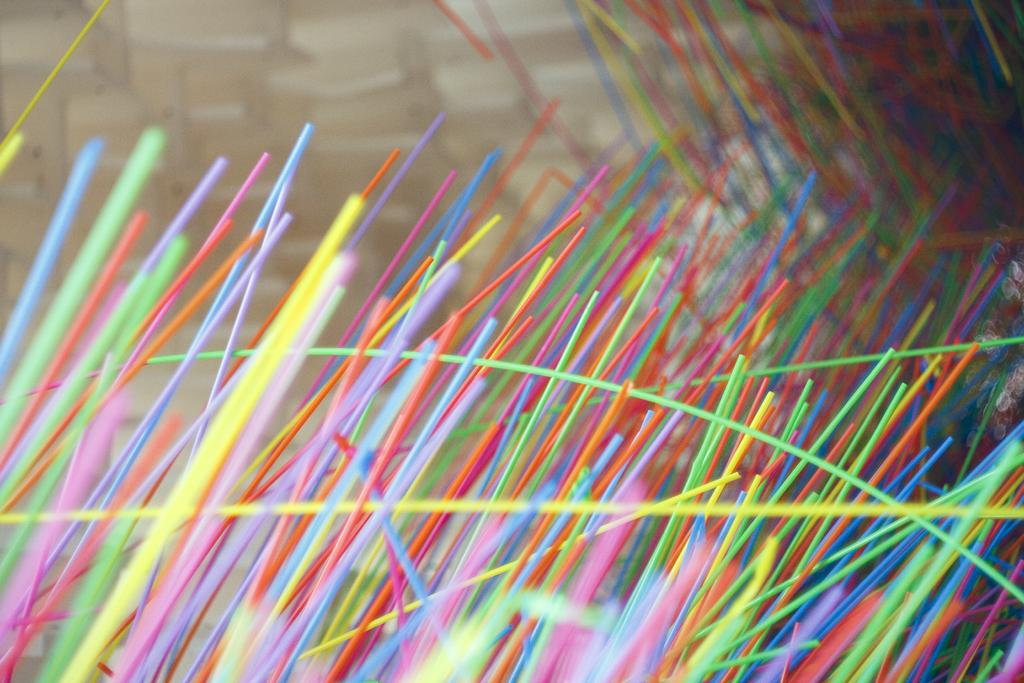What objects are present in the image? There are colorful sticks in the image. Can you describe the appearance of the sticks? The sticks are colorful, which suggests they may have different hues or patterns. What might these sticks be used for? The purpose of the sticks is not explicitly stated, but they could potentially be used for decoration, crafting, or as part of a game or activity. How many icicles are hanging from the sticks in the image? There are no icicles present in the image; it features colorful sticks. What type of fingerprint can be seen on the sticks in the image? There is no fingerprint visible on the sticks in the image. 